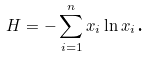Convert formula to latex. <formula><loc_0><loc_0><loc_500><loc_500>H = - \sum _ { i = 1 } ^ { n } x _ { i } \ln x _ { i } \text {.}</formula> 